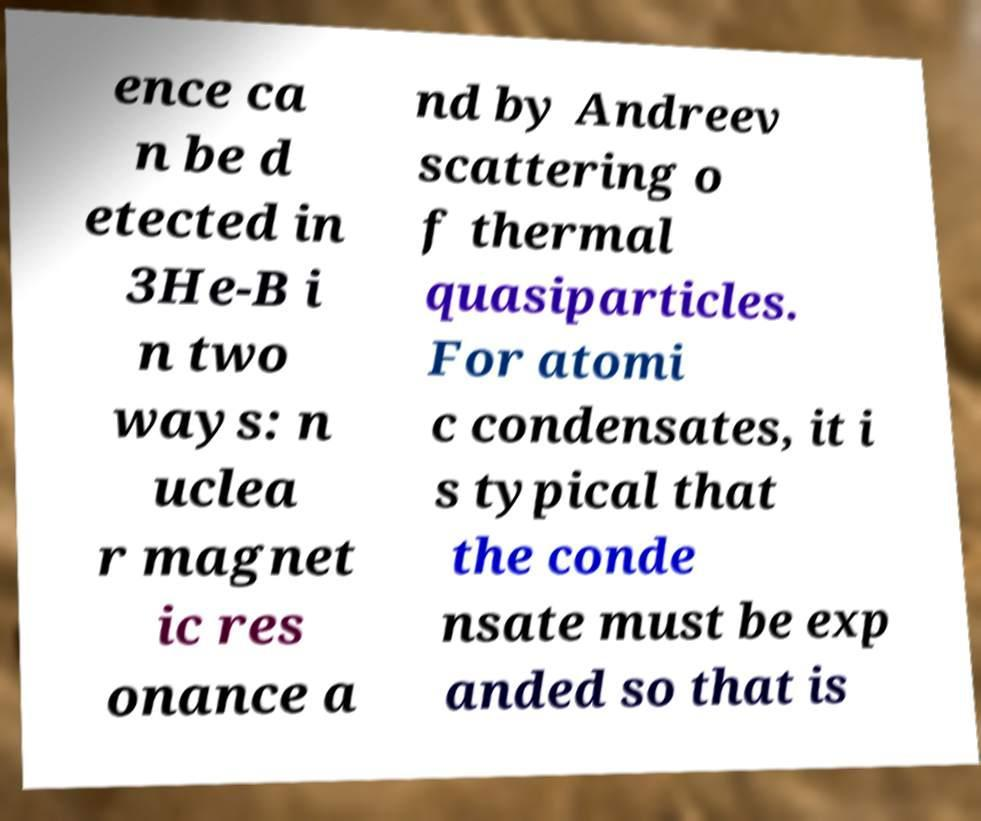Could you extract and type out the text from this image? ence ca n be d etected in 3He-B i n two ways: n uclea r magnet ic res onance a nd by Andreev scattering o f thermal quasiparticles. For atomi c condensates, it i s typical that the conde nsate must be exp anded so that is 